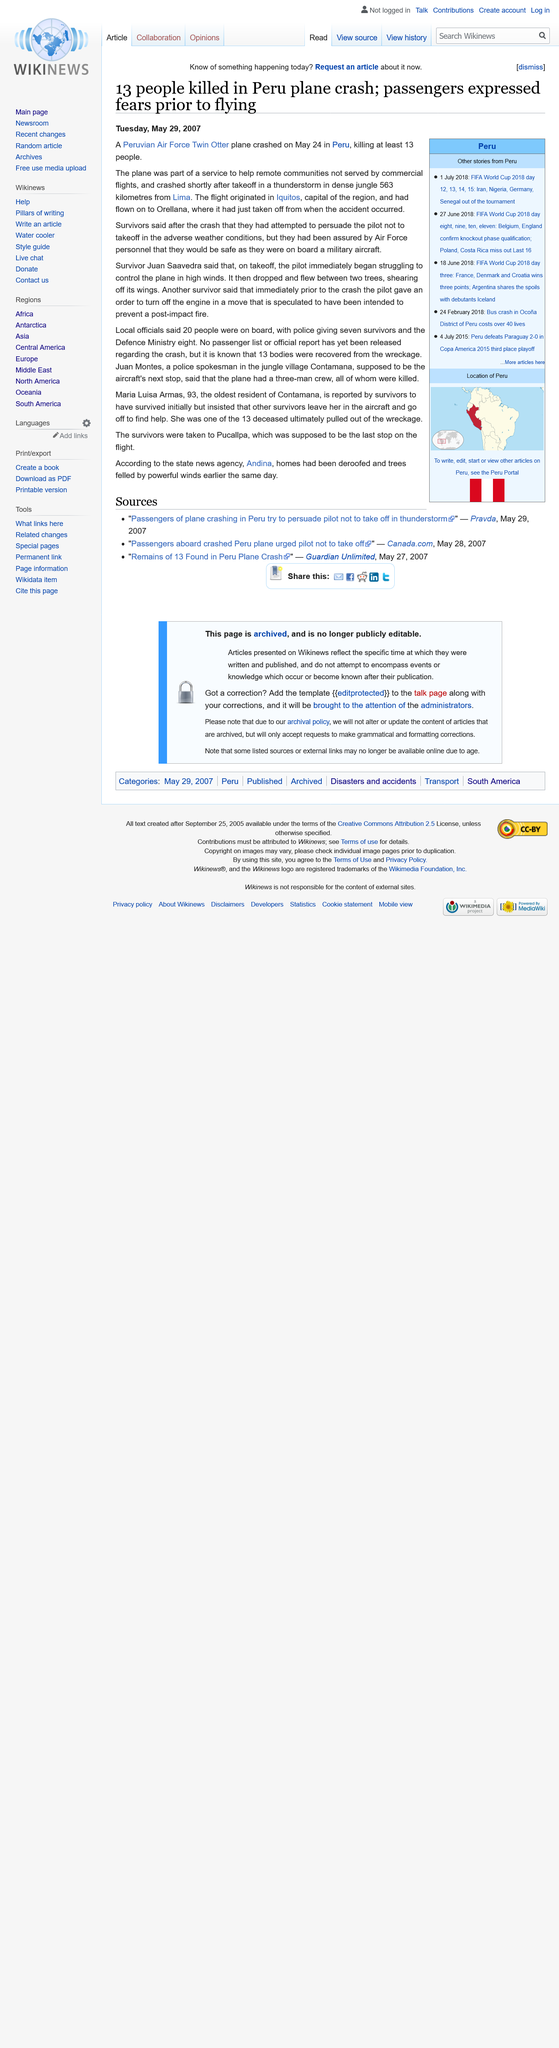Identify some key points in this picture. The plane crash in Peru on March 24th 2007 resulted in the deaths of at least 13 individuals. Orellana, the country, is located in Peru. Lima, the capital city of Peru, is located in the country of Peru. 